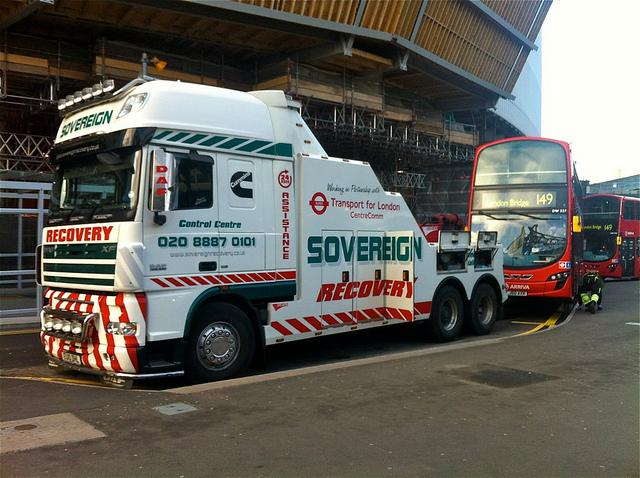Where is Sovereign Recovery located? london 